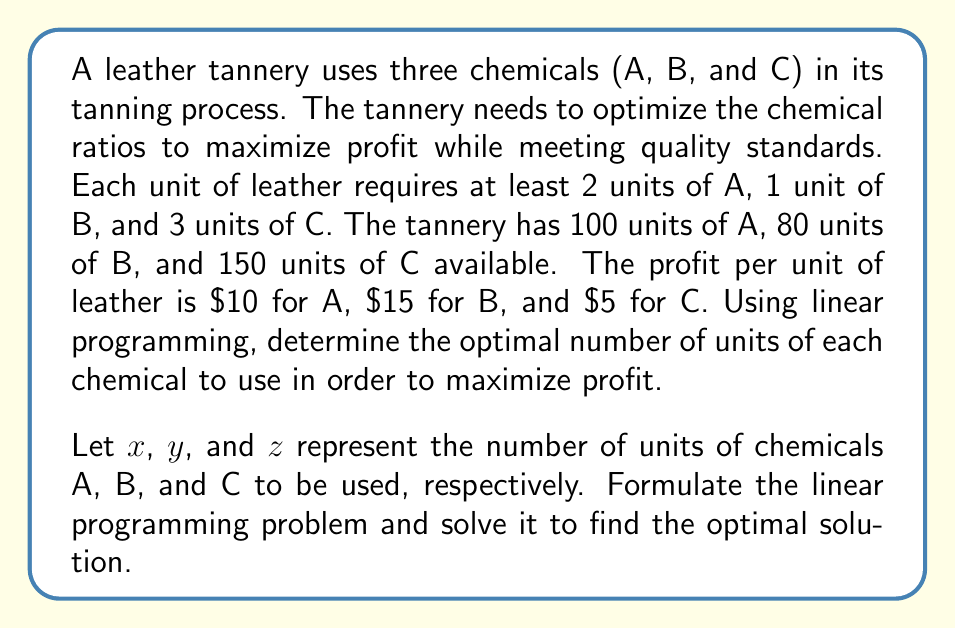Can you solve this math problem? To solve this linear programming problem, we need to follow these steps:

1. Define the objective function:
   Maximize profit: $P = 10x + 15y + 5z$

2. Set up the constraints:
   a) Chemical usage requirements:
      $x \geq 2$
      $y \geq 1$
      $z \geq 3$
   b) Available chemical quantities:
      $x \leq 100$
      $y \leq 80$
      $z \leq 150$

3. Solve the linear programming problem:

   We can use the simplex method or a graphical approach to solve this problem. In this case, we'll use the binding constraints to find the optimal solution.

   The binding constraints are:
   $x = 2$
   $y = 1$
   $z = 3$

   This is because using more chemicals than the minimum required would not increase profit, as we want to maximize the number of leather units produced.

4. Calculate the maximum number of leather units that can be produced:
   
   With chemical A: $100 \div 2 = 50$ units
   With chemical B: $80 \div 1 = 80$ units
   With chemical C: $150 \div 3 = 50$ units

   The limiting factor is the minimum of these values, which is 50 units.

5. Calculate the optimal chemical usage:
   
   A: $50 \times 2 = 100$ units
   B: $50 \times 1 = 50$ units
   C: $50 \times 3 = 150$ units

6. Calculate the maximum profit:
   
   $P = 10(100) + 15(50) + 5(150) = 1000 + 750 + 750 = 2500$

Therefore, the optimal solution is to use 100 units of A, 50 units of B, and 150 units of C to produce 50 units of leather, resulting in a maximum profit of $2500.
Answer: The optimal solution is to use 100 units of chemical A, 50 units of chemical B, and 150 units of chemical C, producing 50 units of leather and generating a maximum profit of $2500. 